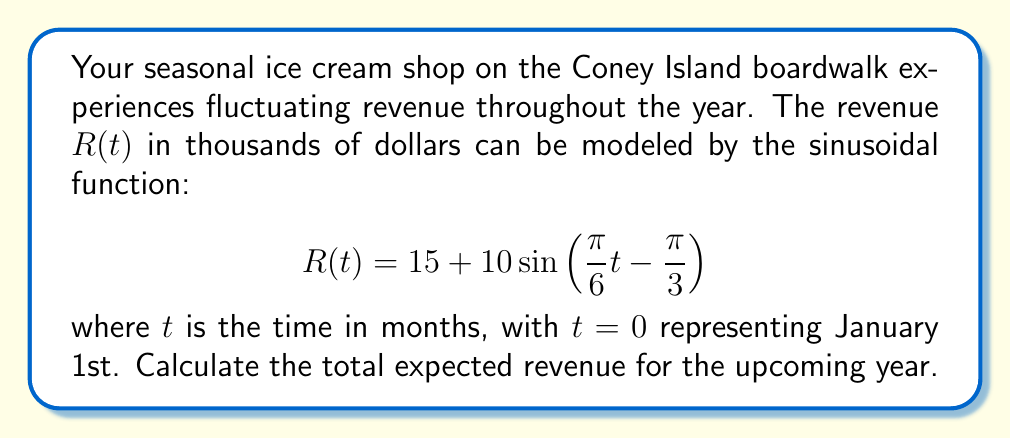Show me your answer to this math problem. To solve this problem, we need to integrate the revenue function over one full year (12 months). Here's the step-by-step solution:

1) The total revenue for the year is given by the definite integral of $R(t)$ from $t=0$ to $t=12$:

   $$\int_0^{12} R(t) dt = \int_0^{12} [15 + 10\sin(\frac{\pi}{6}t - \frac{\pi}{3})] dt$$

2) We can split this into two integrals:

   $$\int_0^{12} 15 dt + \int_0^{12} 10\sin(\frac{\pi}{6}t - \frac{\pi}{3}) dt$$

3) The first integral is straightforward:

   $$\int_0^{12} 15 dt = 15t \bigg|_0^{12} = 15 \cdot 12 = 180$$

4) For the second integral, we can use the formula for integrating sine:

   $$\int \sin(ax + b) dx = -\frac{1}{a}\cos(ax + b) + C$$

   Here, $a = \frac{\pi}{6}$ and $b = -\frac{\pi}{3}$

5) Applying this to our integral:

   $$10 \int_0^{12} \sin(\frac{\pi}{6}t - \frac{\pi}{3}) dt = -10 \cdot \frac{6}{\pi} \cos(\frac{\pi}{6}t - \frac{\pi}{3}) \bigg|_0^{12}$$

6) Evaluating this:

   $$-\frac{60}{\pi} [\cos(2\pi - \frac{\pi}{3}) - \cos(-\frac{\pi}{3})]$$

   $$= -\frac{60}{\pi} [\cos(-\frac{\pi}{3}) - \cos(-\frac{\pi}{3})] = 0$$

7) The total revenue is the sum of these two integrals:

   $$180 + 0 = 180$$

Therefore, the total expected revenue for the year is $180,000.
Answer: $180,000 